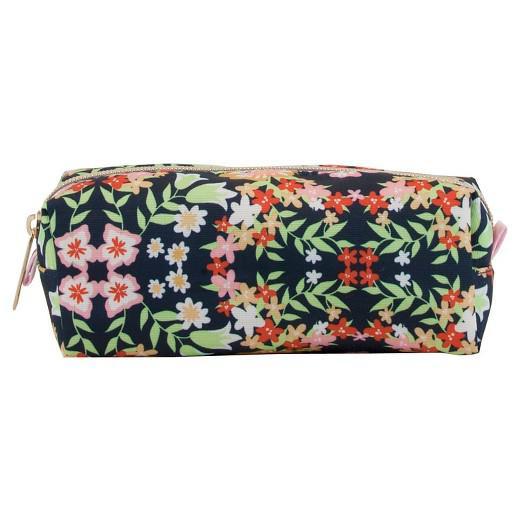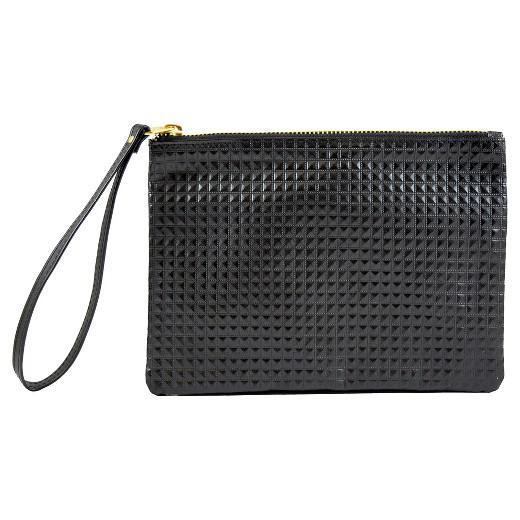The first image is the image on the left, the second image is the image on the right. Given the left and right images, does the statement "One of the images shows a blue bag with white polka dots." hold true? Answer yes or no. No. The first image is the image on the left, the second image is the image on the right. For the images shown, is this caption "The case on the left is more tube shaped than the flatter rectangular case on the right, and the case on the left has a bold print while the case on the right is monochromatic." true? Answer yes or no. Yes. 